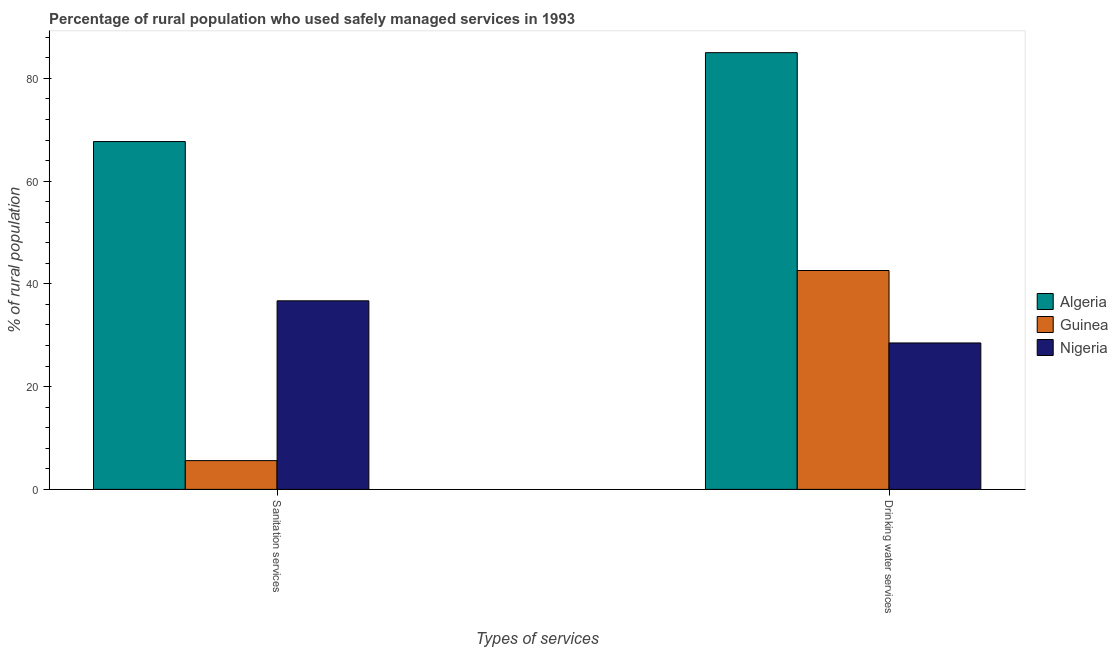How many different coloured bars are there?
Ensure brevity in your answer.  3. Are the number of bars per tick equal to the number of legend labels?
Make the answer very short. Yes. Are the number of bars on each tick of the X-axis equal?
Your response must be concise. Yes. How many bars are there on the 2nd tick from the right?
Make the answer very short. 3. What is the label of the 2nd group of bars from the left?
Give a very brief answer. Drinking water services. What is the percentage of rural population who used sanitation services in Algeria?
Your response must be concise. 67.7. Across all countries, what is the maximum percentage of rural population who used sanitation services?
Ensure brevity in your answer.  67.7. In which country was the percentage of rural population who used sanitation services maximum?
Offer a very short reply. Algeria. In which country was the percentage of rural population who used sanitation services minimum?
Make the answer very short. Guinea. What is the total percentage of rural population who used sanitation services in the graph?
Keep it short and to the point. 110. What is the difference between the percentage of rural population who used drinking water services in Nigeria and the percentage of rural population who used sanitation services in Guinea?
Provide a succinct answer. 22.9. What is the average percentage of rural population who used sanitation services per country?
Keep it short and to the point. 36.67. What is the difference between the percentage of rural population who used sanitation services and percentage of rural population who used drinking water services in Guinea?
Ensure brevity in your answer.  -37. In how many countries, is the percentage of rural population who used sanitation services greater than 28 %?
Make the answer very short. 2. What is the ratio of the percentage of rural population who used sanitation services in Guinea to that in Algeria?
Provide a short and direct response. 0.08. Is the percentage of rural population who used sanitation services in Nigeria less than that in Guinea?
Make the answer very short. No. In how many countries, is the percentage of rural population who used drinking water services greater than the average percentage of rural population who used drinking water services taken over all countries?
Provide a short and direct response. 1. What does the 3rd bar from the left in Drinking water services represents?
Make the answer very short. Nigeria. What does the 1st bar from the right in Sanitation services represents?
Your answer should be compact. Nigeria. Are all the bars in the graph horizontal?
Your answer should be compact. No. Are the values on the major ticks of Y-axis written in scientific E-notation?
Offer a very short reply. No. Does the graph contain grids?
Offer a terse response. No. Where does the legend appear in the graph?
Give a very brief answer. Center right. What is the title of the graph?
Keep it short and to the point. Percentage of rural population who used safely managed services in 1993. What is the label or title of the X-axis?
Your answer should be compact. Types of services. What is the label or title of the Y-axis?
Offer a very short reply. % of rural population. What is the % of rural population in Algeria in Sanitation services?
Your answer should be very brief. 67.7. What is the % of rural population of Nigeria in Sanitation services?
Provide a succinct answer. 36.7. What is the % of rural population in Algeria in Drinking water services?
Offer a terse response. 85. What is the % of rural population in Guinea in Drinking water services?
Make the answer very short. 42.6. Across all Types of services, what is the maximum % of rural population in Guinea?
Offer a terse response. 42.6. Across all Types of services, what is the maximum % of rural population in Nigeria?
Provide a short and direct response. 36.7. Across all Types of services, what is the minimum % of rural population of Algeria?
Give a very brief answer. 67.7. Across all Types of services, what is the minimum % of rural population of Nigeria?
Provide a short and direct response. 28.5. What is the total % of rural population in Algeria in the graph?
Offer a very short reply. 152.7. What is the total % of rural population in Guinea in the graph?
Give a very brief answer. 48.2. What is the total % of rural population of Nigeria in the graph?
Keep it short and to the point. 65.2. What is the difference between the % of rural population in Algeria in Sanitation services and that in Drinking water services?
Ensure brevity in your answer.  -17.3. What is the difference between the % of rural population in Guinea in Sanitation services and that in Drinking water services?
Give a very brief answer. -37. What is the difference between the % of rural population in Nigeria in Sanitation services and that in Drinking water services?
Your answer should be compact. 8.2. What is the difference between the % of rural population in Algeria in Sanitation services and the % of rural population in Guinea in Drinking water services?
Give a very brief answer. 25.1. What is the difference between the % of rural population in Algeria in Sanitation services and the % of rural population in Nigeria in Drinking water services?
Your answer should be compact. 39.2. What is the difference between the % of rural population of Guinea in Sanitation services and the % of rural population of Nigeria in Drinking water services?
Make the answer very short. -22.9. What is the average % of rural population in Algeria per Types of services?
Offer a very short reply. 76.35. What is the average % of rural population in Guinea per Types of services?
Give a very brief answer. 24.1. What is the average % of rural population in Nigeria per Types of services?
Your response must be concise. 32.6. What is the difference between the % of rural population in Algeria and % of rural population in Guinea in Sanitation services?
Provide a succinct answer. 62.1. What is the difference between the % of rural population in Guinea and % of rural population in Nigeria in Sanitation services?
Keep it short and to the point. -31.1. What is the difference between the % of rural population of Algeria and % of rural population of Guinea in Drinking water services?
Keep it short and to the point. 42.4. What is the difference between the % of rural population in Algeria and % of rural population in Nigeria in Drinking water services?
Provide a succinct answer. 56.5. What is the difference between the % of rural population of Guinea and % of rural population of Nigeria in Drinking water services?
Your response must be concise. 14.1. What is the ratio of the % of rural population in Algeria in Sanitation services to that in Drinking water services?
Give a very brief answer. 0.8. What is the ratio of the % of rural population in Guinea in Sanitation services to that in Drinking water services?
Offer a terse response. 0.13. What is the ratio of the % of rural population of Nigeria in Sanitation services to that in Drinking water services?
Make the answer very short. 1.29. What is the difference between the highest and the second highest % of rural population of Algeria?
Your answer should be compact. 17.3. What is the difference between the highest and the lowest % of rural population in Algeria?
Offer a terse response. 17.3. 